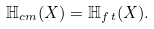<formula> <loc_0><loc_0><loc_500><loc_500>\mathbb { H } _ { c m } ( X ) = \mathbb { H } _ { f \, t } ( X ) .</formula> 